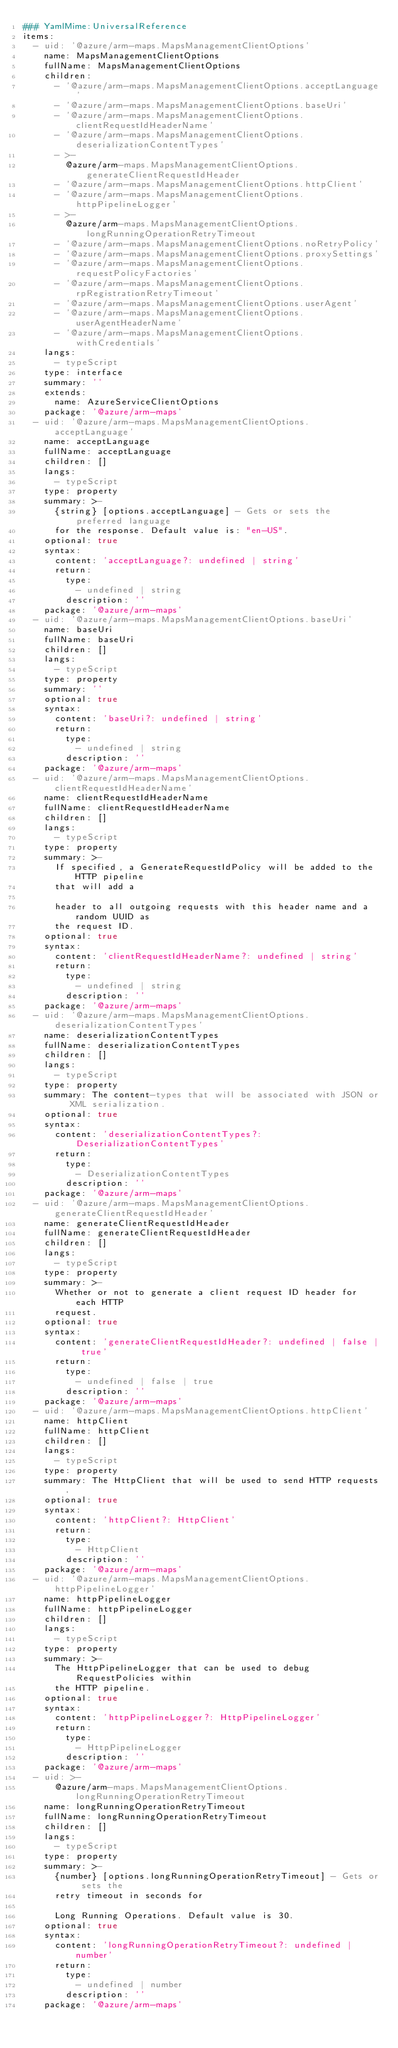<code> <loc_0><loc_0><loc_500><loc_500><_YAML_>### YamlMime:UniversalReference
items:
  - uid: '@azure/arm-maps.MapsManagementClientOptions'
    name: MapsManagementClientOptions
    fullName: MapsManagementClientOptions
    children:
      - '@azure/arm-maps.MapsManagementClientOptions.acceptLanguage'
      - '@azure/arm-maps.MapsManagementClientOptions.baseUri'
      - '@azure/arm-maps.MapsManagementClientOptions.clientRequestIdHeaderName'
      - '@azure/arm-maps.MapsManagementClientOptions.deserializationContentTypes'
      - >-
        @azure/arm-maps.MapsManagementClientOptions.generateClientRequestIdHeader
      - '@azure/arm-maps.MapsManagementClientOptions.httpClient'
      - '@azure/arm-maps.MapsManagementClientOptions.httpPipelineLogger'
      - >-
        @azure/arm-maps.MapsManagementClientOptions.longRunningOperationRetryTimeout
      - '@azure/arm-maps.MapsManagementClientOptions.noRetryPolicy'
      - '@azure/arm-maps.MapsManagementClientOptions.proxySettings'
      - '@azure/arm-maps.MapsManagementClientOptions.requestPolicyFactories'
      - '@azure/arm-maps.MapsManagementClientOptions.rpRegistrationRetryTimeout'
      - '@azure/arm-maps.MapsManagementClientOptions.userAgent'
      - '@azure/arm-maps.MapsManagementClientOptions.userAgentHeaderName'
      - '@azure/arm-maps.MapsManagementClientOptions.withCredentials'
    langs:
      - typeScript
    type: interface
    summary: ''
    extends:
      name: AzureServiceClientOptions
    package: '@azure/arm-maps'
  - uid: '@azure/arm-maps.MapsManagementClientOptions.acceptLanguage'
    name: acceptLanguage
    fullName: acceptLanguage
    children: []
    langs:
      - typeScript
    type: property
    summary: >-
      {string} [options.acceptLanguage] - Gets or sets the preferred language
      for the response. Default value is: "en-US".
    optional: true
    syntax:
      content: 'acceptLanguage?: undefined | string'
      return:
        type:
          - undefined | string
        description: ''
    package: '@azure/arm-maps'
  - uid: '@azure/arm-maps.MapsManagementClientOptions.baseUri'
    name: baseUri
    fullName: baseUri
    children: []
    langs:
      - typeScript
    type: property
    summary: ''
    optional: true
    syntax:
      content: 'baseUri?: undefined | string'
      return:
        type:
          - undefined | string
        description: ''
    package: '@azure/arm-maps'
  - uid: '@azure/arm-maps.MapsManagementClientOptions.clientRequestIdHeaderName'
    name: clientRequestIdHeaderName
    fullName: clientRequestIdHeaderName
    children: []
    langs:
      - typeScript
    type: property
    summary: >-
      If specified, a GenerateRequestIdPolicy will be added to the HTTP pipeline
      that will add a

      header to all outgoing requests with this header name and a random UUID as
      the request ID.
    optional: true
    syntax:
      content: 'clientRequestIdHeaderName?: undefined | string'
      return:
        type:
          - undefined | string
        description: ''
    package: '@azure/arm-maps'
  - uid: '@azure/arm-maps.MapsManagementClientOptions.deserializationContentTypes'
    name: deserializationContentTypes
    fullName: deserializationContentTypes
    children: []
    langs:
      - typeScript
    type: property
    summary: The content-types that will be associated with JSON or XML serialization.
    optional: true
    syntax:
      content: 'deserializationContentTypes?: DeserializationContentTypes'
      return:
        type:
          - DeserializationContentTypes
        description: ''
    package: '@azure/arm-maps'
  - uid: '@azure/arm-maps.MapsManagementClientOptions.generateClientRequestIdHeader'
    name: generateClientRequestIdHeader
    fullName: generateClientRequestIdHeader
    children: []
    langs:
      - typeScript
    type: property
    summary: >-
      Whether or not to generate a client request ID header for each HTTP
      request.
    optional: true
    syntax:
      content: 'generateClientRequestIdHeader?: undefined | false | true'
      return:
        type:
          - undefined | false | true
        description: ''
    package: '@azure/arm-maps'
  - uid: '@azure/arm-maps.MapsManagementClientOptions.httpClient'
    name: httpClient
    fullName: httpClient
    children: []
    langs:
      - typeScript
    type: property
    summary: The HttpClient that will be used to send HTTP requests.
    optional: true
    syntax:
      content: 'httpClient?: HttpClient'
      return:
        type:
          - HttpClient
        description: ''
    package: '@azure/arm-maps'
  - uid: '@azure/arm-maps.MapsManagementClientOptions.httpPipelineLogger'
    name: httpPipelineLogger
    fullName: httpPipelineLogger
    children: []
    langs:
      - typeScript
    type: property
    summary: >-
      The HttpPipelineLogger that can be used to debug RequestPolicies within
      the HTTP pipeline.
    optional: true
    syntax:
      content: 'httpPipelineLogger?: HttpPipelineLogger'
      return:
        type:
          - HttpPipelineLogger
        description: ''
    package: '@azure/arm-maps'
  - uid: >-
      @azure/arm-maps.MapsManagementClientOptions.longRunningOperationRetryTimeout
    name: longRunningOperationRetryTimeout
    fullName: longRunningOperationRetryTimeout
    children: []
    langs:
      - typeScript
    type: property
    summary: >-
      {number} [options.longRunningOperationRetryTimeout] - Gets or sets the
      retry timeout in seconds for

      Long Running Operations. Default value is 30.
    optional: true
    syntax:
      content: 'longRunningOperationRetryTimeout?: undefined | number'
      return:
        type:
          - undefined | number
        description: ''
    package: '@azure/arm-maps'</code> 